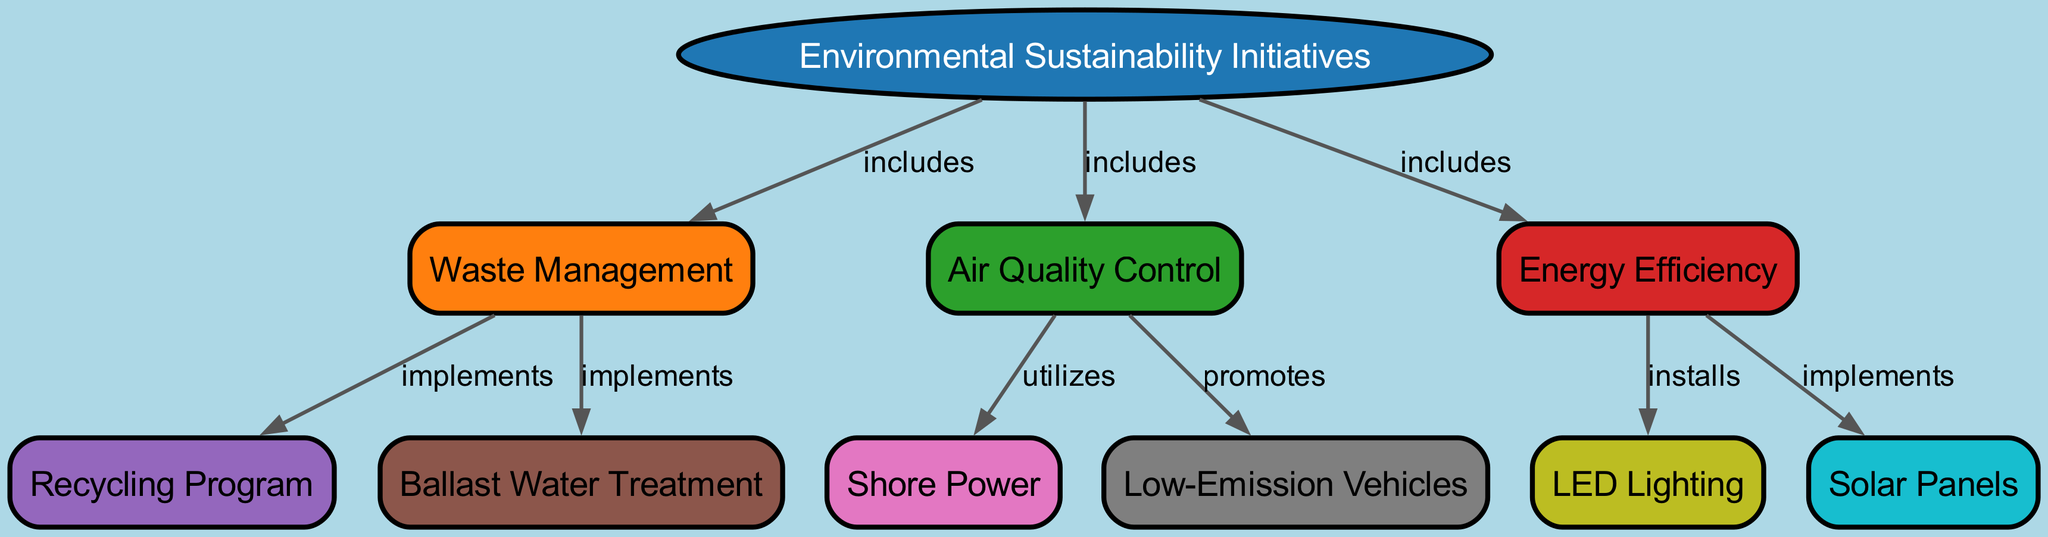What are the three main categories included in Environmental Sustainability Initiatives? The diagram shows three branches stemming from the "Environmental Sustainability Initiatives" node, which are "Waste Management," "Air Quality Control," and "Energy Efficiency."
Answer: Waste Management, Air Quality Control, Energy Efficiency How many nodes are present in this diagram? By counting each distinct subtopic and the main topic in the diagram, we can determine that there are a total of ten nodes.
Answer: Ten What initiative implements the Recycling Program? The diagram connects "Waste Management" with "Recycling Program" through the label "implements," indicating that the Recycling Program is part of Waste Management initiatives.
Answer: Waste Management Which category promotes Low-Emission Vehicles? The diagram illustrates that the "Air Quality Control" category has an arrow pointing to "Low-Emission Vehicles" labeled "promotes," meaning this initiative is part of Air Quality Control.
Answer: Air Quality Control What energy efficiency measure is associated with LED Lighting? The diagram reveals that "Energy Efficiency" has a direct link to "LED Lighting," indicated by the label "installs," thereby implying that LED Lighting is a measure included in Energy Efficiency.
Answer: Energy Efficiency Which initiative utilizes Shore Power? The diagram shows an arrow from "Air Quality Control" to "Shore Power" with the label "utilizes," indicating that Shore Power is part of the initiatives for Air Quality Control.
Answer: Air Quality Control How does Ballast Water Treatment relate to Waste Management? The diagram shows that "Waste Management" includes an initiative for "Ballast Water Treatment," meaning it falls under the waste management measures employed at the port.
Answer: Waste Management Which two measures are distinctly marked under Energy Efficiency? The diagram displays two initiatives connecting to "Energy Efficiency": "LED Lighting" and "Solar Panels," both of which contribute to enhancing energy efficiency at the port.
Answer: LED Lighting, Solar Panels 